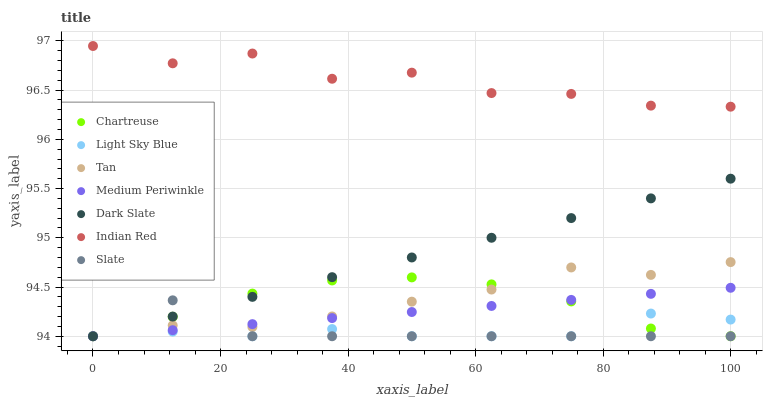Does Light Sky Blue have the minimum area under the curve?
Answer yes or no. Yes. Does Indian Red have the maximum area under the curve?
Answer yes or no. Yes. Does Medium Periwinkle have the minimum area under the curve?
Answer yes or no. No. Does Medium Periwinkle have the maximum area under the curve?
Answer yes or no. No. Is Medium Periwinkle the smoothest?
Answer yes or no. Yes. Is Indian Red the roughest?
Answer yes or no. Yes. Is Dark Slate the smoothest?
Answer yes or no. No. Is Dark Slate the roughest?
Answer yes or no. No. Does Slate have the lowest value?
Answer yes or no. Yes. Does Indian Red have the lowest value?
Answer yes or no. No. Does Indian Red have the highest value?
Answer yes or no. Yes. Does Medium Periwinkle have the highest value?
Answer yes or no. No. Is Tan less than Indian Red?
Answer yes or no. Yes. Is Indian Red greater than Medium Periwinkle?
Answer yes or no. Yes. Does Chartreuse intersect Dark Slate?
Answer yes or no. Yes. Is Chartreuse less than Dark Slate?
Answer yes or no. No. Is Chartreuse greater than Dark Slate?
Answer yes or no. No. Does Tan intersect Indian Red?
Answer yes or no. No. 